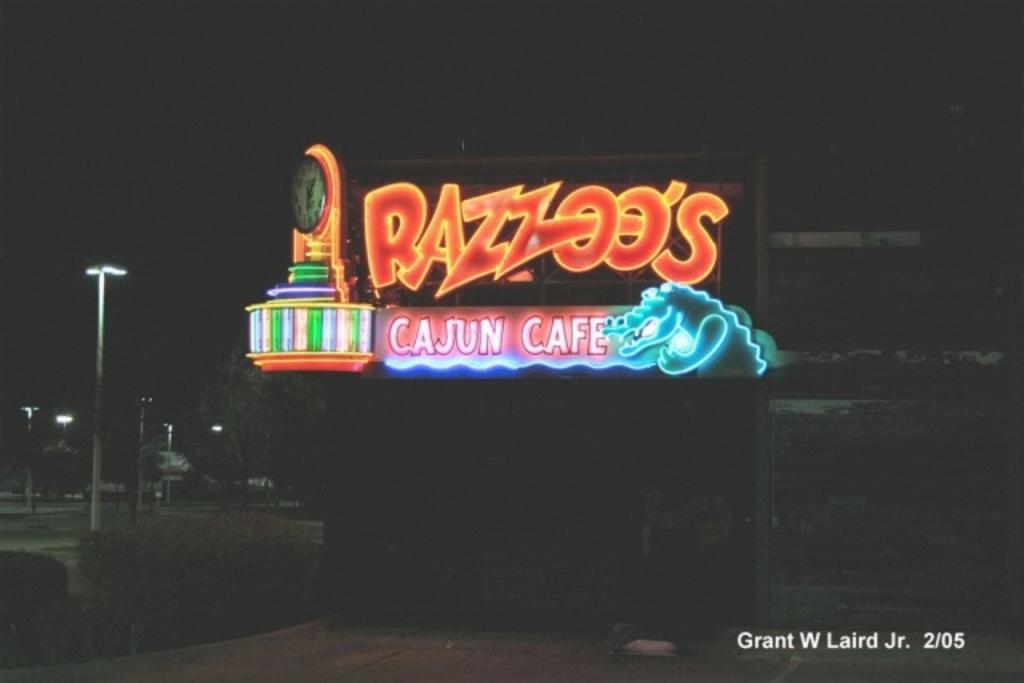<image>
Provide a brief description of the given image. A sign for a Cajun cafe is lit up in several colors. 